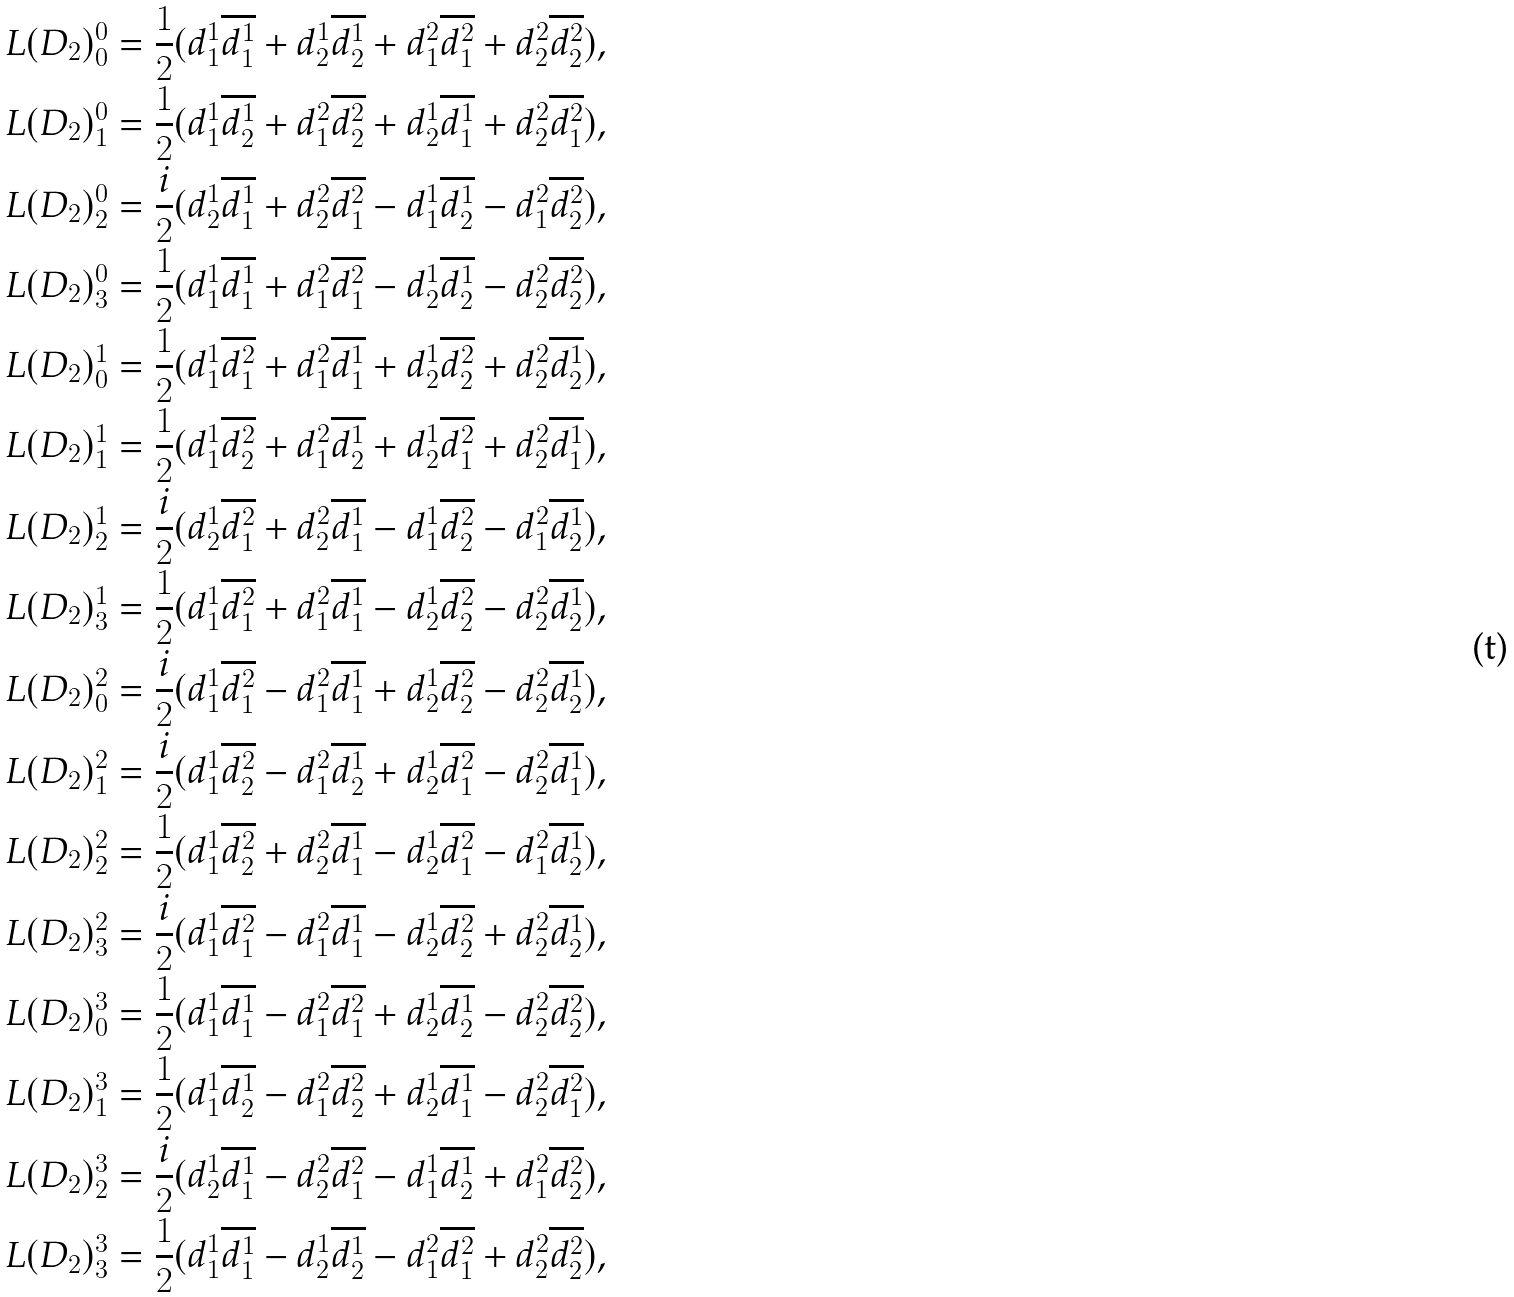<formula> <loc_0><loc_0><loc_500><loc_500>L ( D _ { 2 } ) ^ { 0 } _ { 0 } & = \frac { 1 } { 2 } ( d ^ { 1 } _ { 1 } \overline { d ^ { 1 } _ { 1 } } + d ^ { 1 } _ { 2 } \overline { d ^ { 1 } _ { 2 } } + d ^ { 2 } _ { 1 } \overline { d ^ { 2 } _ { 1 } } + d ^ { 2 } _ { 2 } \overline { d ^ { 2 } _ { 2 } } ) , \\ L ( D _ { 2 } ) ^ { 0 } _ { 1 } & = \frac { 1 } { 2 } ( d ^ { 1 } _ { 1 } \overline { d ^ { 1 } _ { 2 } } + d ^ { 2 } _ { 1 } \overline { d ^ { 2 } _ { 2 } } + d ^ { 1 } _ { 2 } \overline { d ^ { 1 } _ { 1 } } + d ^ { 2 } _ { 2 } \overline { d ^ { 2 } _ { 1 } } ) , \\ L ( D _ { 2 } ) ^ { 0 } _ { 2 } & = \frac { i } { 2 } ( d ^ { 1 } _ { 2 } \overline { d ^ { 1 } _ { 1 } } + d ^ { 2 } _ { 2 } \overline { d ^ { 2 } _ { 1 } } - d ^ { 1 } _ { 1 } \overline { d ^ { 1 } _ { 2 } } - d ^ { 2 } _ { 1 } \overline { d ^ { 2 } _ { 2 } } ) , \\ L ( D _ { 2 } ) ^ { 0 } _ { 3 } & = \frac { 1 } { 2 } ( d ^ { 1 } _ { 1 } \overline { d ^ { 1 } _ { 1 } } + d ^ { 2 } _ { 1 } \overline { d ^ { 2 } _ { 1 } } - d ^ { 1 } _ { 2 } \overline { d ^ { 1 } _ { 2 } } - d ^ { 2 } _ { 2 } \overline { d ^ { 2 } _ { 2 } } ) , \\ L ( D _ { 2 } ) ^ { 1 } _ { 0 } & = \frac { 1 } { 2 } ( d ^ { 1 } _ { 1 } \overline { d ^ { 2 } _ { 1 } } + d ^ { 2 } _ { 1 } \overline { d ^ { 1 } _ { 1 } } + d ^ { 1 } _ { 2 } \overline { d ^ { 2 } _ { 2 } } + d ^ { 2 } _ { 2 } \overline { d ^ { 1 } _ { 2 } } ) , \\ L ( D _ { 2 } ) ^ { 1 } _ { 1 } & = \frac { 1 } { 2 } ( d ^ { 1 } _ { 1 } \overline { d ^ { 2 } _ { 2 } } + d ^ { 2 } _ { 1 } \overline { d ^ { 1 } _ { 2 } } + d ^ { 1 } _ { 2 } \overline { d ^ { 2 } _ { 1 } } + d ^ { 2 } _ { 2 } \overline { d ^ { 1 } _ { 1 } } ) , \\ L ( D _ { 2 } ) ^ { 1 } _ { 2 } & = \frac { i } { 2 } ( d ^ { 1 } _ { 2 } \overline { d ^ { 2 } _ { 1 } } + d ^ { 2 } _ { 2 } \overline { d ^ { 1 } _ { 1 } } - d ^ { 1 } _ { 1 } \overline { d ^ { 2 } _ { 2 } } - d ^ { 2 } _ { 1 } \overline { d ^ { 1 } _ { 2 } } ) , \\ L ( D _ { 2 } ) ^ { 1 } _ { 3 } & = \frac { 1 } { 2 } ( d ^ { 1 } _ { 1 } \overline { d ^ { 2 } _ { 1 } } + d ^ { 2 } _ { 1 } \overline { d ^ { 1 } _ { 1 } } - d ^ { 1 } _ { 2 } \overline { d ^ { 2 } _ { 2 } } - d ^ { 2 } _ { 2 } \overline { d ^ { 1 } _ { 2 } } ) , \\ L ( D _ { 2 } ) ^ { 2 } _ { 0 } & = \frac { i } { 2 } ( d ^ { 1 } _ { 1 } \overline { d ^ { 2 } _ { 1 } } - d ^ { 2 } _ { 1 } \overline { d ^ { 1 } _ { 1 } } + d ^ { 1 } _ { 2 } \overline { d ^ { 2 } _ { 2 } } - d ^ { 2 } _ { 2 } \overline { d ^ { 1 } _ { 2 } } ) , \\ L ( D _ { 2 } ) ^ { 2 } _ { 1 } & = \frac { i } { 2 } ( d ^ { 1 } _ { 1 } \overline { d ^ { 2 } _ { 2 } } - d ^ { 2 } _ { 1 } \overline { d ^ { 1 } _ { 2 } } + d ^ { 1 } _ { 2 } \overline { d ^ { 2 } _ { 1 } } - d ^ { 2 } _ { 2 } \overline { d ^ { 1 } _ { 1 } } ) , \\ L ( D _ { 2 } ) ^ { 2 } _ { 2 } & = \frac { 1 } { 2 } ( d ^ { 1 } _ { 1 } \overline { d ^ { 2 } _ { 2 } } + d ^ { 2 } _ { 2 } \overline { d ^ { 1 } _ { 1 } } - d ^ { 1 } _ { 2 } \overline { d ^ { 2 } _ { 1 } } - d ^ { 2 } _ { 1 } \overline { d ^ { 1 } _ { 2 } } ) , \\ L ( D _ { 2 } ) ^ { 2 } _ { 3 } & = \frac { i } { 2 } ( d ^ { 1 } _ { 1 } \overline { d ^ { 2 } _ { 1 } } - d ^ { 2 } _ { 1 } \overline { d ^ { 1 } _ { 1 } } - d ^ { 1 } _ { 2 } \overline { d ^ { 2 } _ { 2 } } + d ^ { 2 } _ { 2 } \overline { d ^ { 1 } _ { 2 } } ) , \\ L ( D _ { 2 } ) ^ { 3 } _ { 0 } & = \frac { 1 } { 2 } ( d ^ { 1 } _ { 1 } \overline { d ^ { 1 } _ { 1 } } - d ^ { 2 } _ { 1 } \overline { d ^ { 2 } _ { 1 } } + d ^ { 1 } _ { 2 } \overline { d ^ { 1 } _ { 2 } } - d ^ { 2 } _ { 2 } \overline { d ^ { 2 } _ { 2 } } ) , \\ L ( D _ { 2 } ) ^ { 3 } _ { 1 } & = \frac { 1 } { 2 } ( d ^ { 1 } _ { 1 } \overline { d ^ { 1 } _ { 2 } } - d ^ { 2 } _ { 1 } \overline { d ^ { 2 } _ { 2 } } + d ^ { 1 } _ { 2 } \overline { d ^ { 1 } _ { 1 } } - d ^ { 2 } _ { 2 } \overline { d ^ { 2 } _ { 1 } } ) , \\ L ( D _ { 2 } ) ^ { 3 } _ { 2 } & = \frac { i } { 2 } ( d ^ { 1 } _ { 2 } \overline { d ^ { 1 } _ { 1 } } - d ^ { 2 } _ { 2 } \overline { d ^ { 2 } _ { 1 } } - d ^ { 1 } _ { 1 } \overline { d ^ { 1 } _ { 2 } } + d ^ { 2 } _ { 1 } \overline { d ^ { 2 } _ { 2 } } ) , \\ L ( D _ { 2 } ) ^ { 3 } _ { 3 } & = \frac { 1 } { 2 } ( d ^ { 1 } _ { 1 } \overline { d ^ { 1 } _ { 1 } } - d ^ { 1 } _ { 2 } \overline { d ^ { 1 } _ { 2 } } - d ^ { 2 } _ { 1 } \overline { d ^ { 2 } _ { 1 } } + d ^ { 2 } _ { 2 } \overline { d ^ { 2 } _ { 2 } } ) ,</formula> 